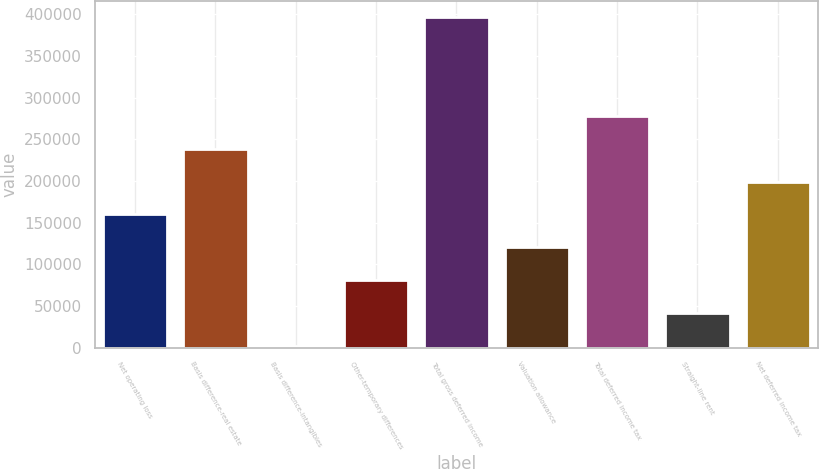Convert chart to OTSL. <chart><loc_0><loc_0><loc_500><loc_500><bar_chart><fcel>Net operating loss<fcel>Basis difference-real estate<fcel>Basis difference-intangibles<fcel>Other-temporary differences<fcel>Total gross deferred income<fcel>Valuation allowance<fcel>Total deferred income tax<fcel>Straight-line rent<fcel>Net deferred income tax<nl><fcel>159882<fcel>238710<fcel>2225<fcel>81053.4<fcel>396367<fcel>120468<fcel>278124<fcel>41639.2<fcel>199296<nl></chart> 